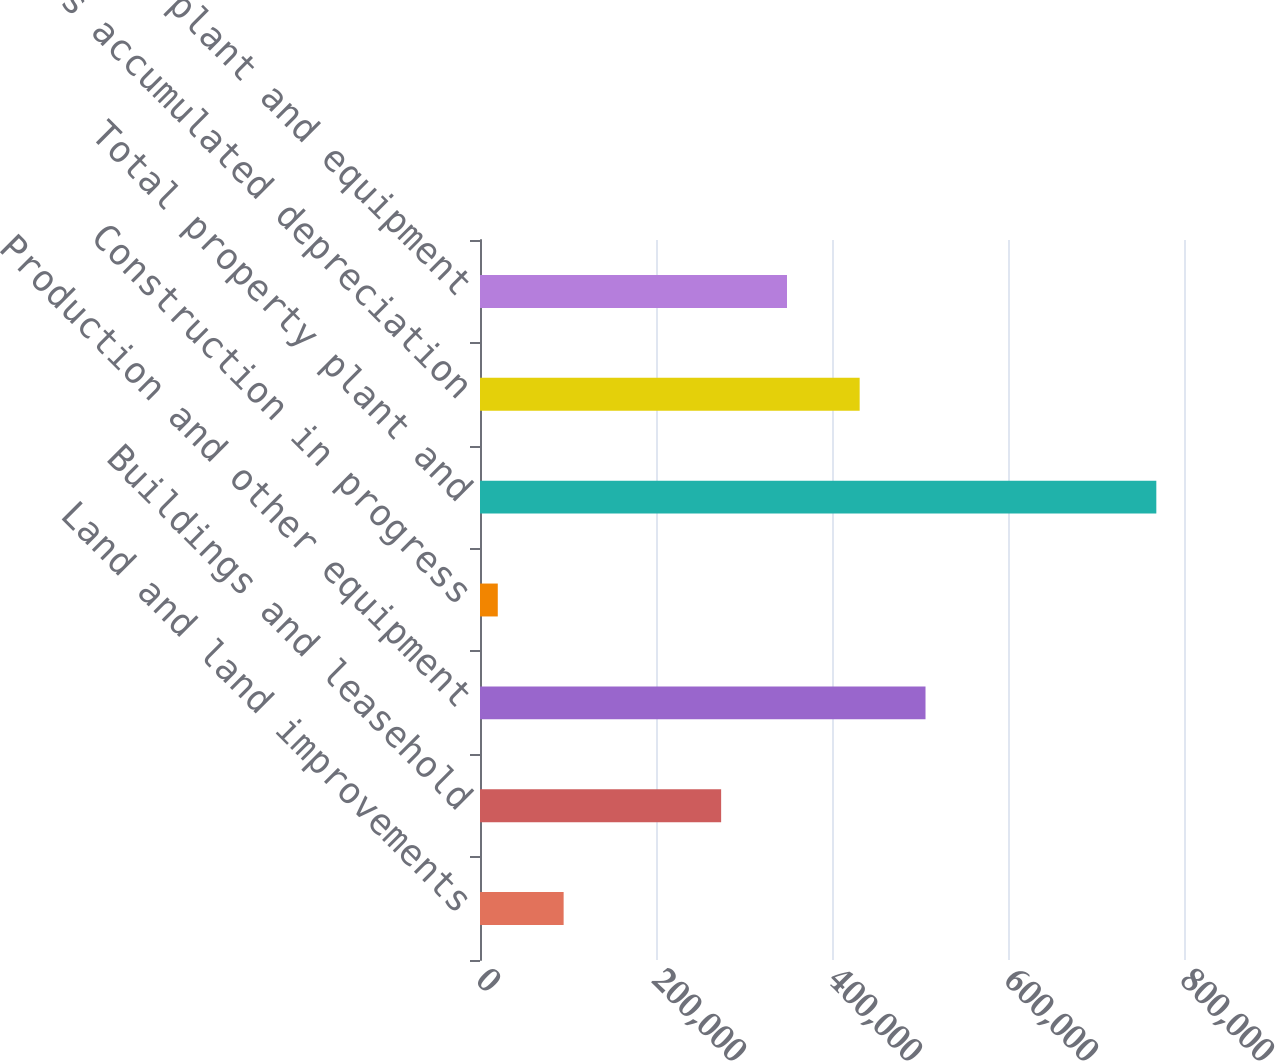<chart> <loc_0><loc_0><loc_500><loc_500><bar_chart><fcel>Land and land improvements<fcel>Buildings and leasehold<fcel>Production and other equipment<fcel>Construction in progress<fcel>Total property plant and<fcel>Less accumulated depreciation<fcel>Property plant and equipment<nl><fcel>95038.5<fcel>274021<fcel>506266<fcel>20204<fcel>768549<fcel>431431<fcel>348856<nl></chart> 